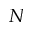<formula> <loc_0><loc_0><loc_500><loc_500>N</formula> 